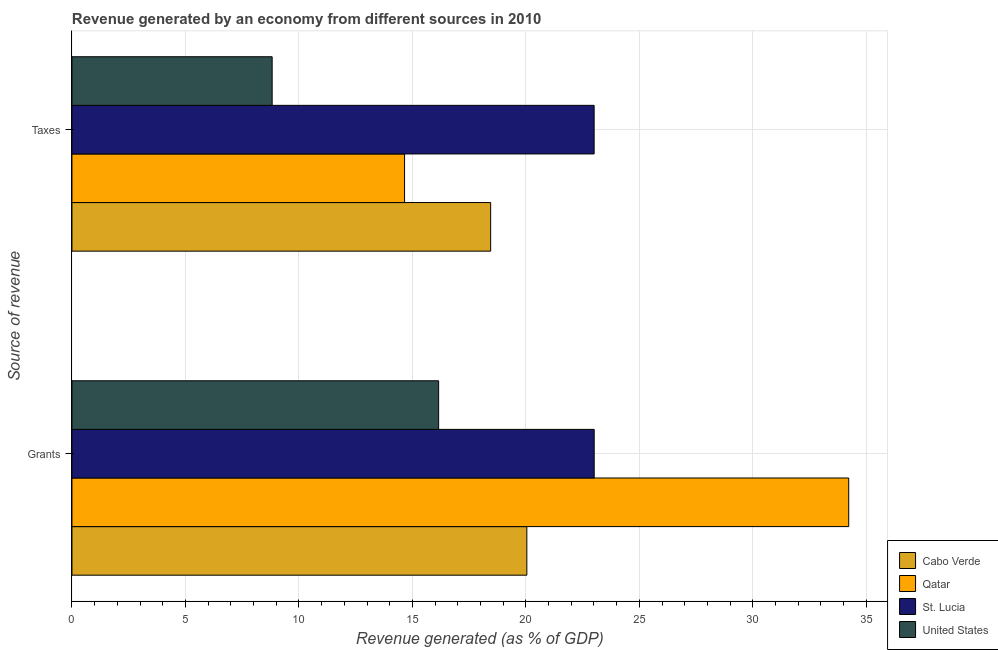How many bars are there on the 2nd tick from the top?
Give a very brief answer. 4. How many bars are there on the 1st tick from the bottom?
Your answer should be compact. 4. What is the label of the 1st group of bars from the top?
Offer a terse response. Taxes. What is the revenue generated by taxes in United States?
Offer a terse response. 8.82. Across all countries, what is the maximum revenue generated by taxes?
Provide a succinct answer. 23.01. Across all countries, what is the minimum revenue generated by taxes?
Offer a very short reply. 8.82. In which country was the revenue generated by taxes maximum?
Keep it short and to the point. St. Lucia. In which country was the revenue generated by taxes minimum?
Your response must be concise. United States. What is the total revenue generated by grants in the graph?
Keep it short and to the point. 93.43. What is the difference between the revenue generated by taxes in St. Lucia and that in Qatar?
Your answer should be compact. 8.35. What is the difference between the revenue generated by taxes in Qatar and the revenue generated by grants in St. Lucia?
Your response must be concise. -8.36. What is the average revenue generated by grants per country?
Your answer should be very brief. 23.36. What is the difference between the revenue generated by taxes and revenue generated by grants in Qatar?
Make the answer very short. -19.57. In how many countries, is the revenue generated by grants greater than 27 %?
Offer a terse response. 1. What is the ratio of the revenue generated by grants in Qatar to that in United States?
Your answer should be very brief. 2.12. Is the revenue generated by taxes in United States less than that in Qatar?
Give a very brief answer. Yes. In how many countries, is the revenue generated by taxes greater than the average revenue generated by taxes taken over all countries?
Offer a terse response. 2. What does the 4th bar from the top in Grants represents?
Give a very brief answer. Cabo Verde. What does the 3rd bar from the bottom in Taxes represents?
Give a very brief answer. St. Lucia. How many countries are there in the graph?
Keep it short and to the point. 4. What is the difference between two consecutive major ticks on the X-axis?
Make the answer very short. 5. Are the values on the major ticks of X-axis written in scientific E-notation?
Offer a very short reply. No. Does the graph contain any zero values?
Your response must be concise. No. Where does the legend appear in the graph?
Provide a short and direct response. Bottom right. How are the legend labels stacked?
Provide a succinct answer. Vertical. What is the title of the graph?
Keep it short and to the point. Revenue generated by an economy from different sources in 2010. What is the label or title of the X-axis?
Provide a short and direct response. Revenue generated (as % of GDP). What is the label or title of the Y-axis?
Offer a terse response. Source of revenue. What is the Revenue generated (as % of GDP) of Cabo Verde in Grants?
Keep it short and to the point. 20.04. What is the Revenue generated (as % of GDP) in Qatar in Grants?
Provide a succinct answer. 34.22. What is the Revenue generated (as % of GDP) of St. Lucia in Grants?
Offer a terse response. 23.01. What is the Revenue generated (as % of GDP) in United States in Grants?
Your answer should be very brief. 16.16. What is the Revenue generated (as % of GDP) of Cabo Verde in Taxes?
Your answer should be very brief. 18.45. What is the Revenue generated (as % of GDP) in Qatar in Taxes?
Your answer should be very brief. 14.65. What is the Revenue generated (as % of GDP) in St. Lucia in Taxes?
Make the answer very short. 23.01. What is the Revenue generated (as % of GDP) in United States in Taxes?
Give a very brief answer. 8.82. Across all Source of revenue, what is the maximum Revenue generated (as % of GDP) in Cabo Verde?
Make the answer very short. 20.04. Across all Source of revenue, what is the maximum Revenue generated (as % of GDP) of Qatar?
Your response must be concise. 34.22. Across all Source of revenue, what is the maximum Revenue generated (as % of GDP) in St. Lucia?
Make the answer very short. 23.01. Across all Source of revenue, what is the maximum Revenue generated (as % of GDP) in United States?
Your answer should be very brief. 16.16. Across all Source of revenue, what is the minimum Revenue generated (as % of GDP) of Cabo Verde?
Keep it short and to the point. 18.45. Across all Source of revenue, what is the minimum Revenue generated (as % of GDP) of Qatar?
Make the answer very short. 14.65. Across all Source of revenue, what is the minimum Revenue generated (as % of GDP) of St. Lucia?
Give a very brief answer. 23.01. Across all Source of revenue, what is the minimum Revenue generated (as % of GDP) in United States?
Offer a very short reply. 8.82. What is the total Revenue generated (as % of GDP) in Cabo Verde in the graph?
Provide a succinct answer. 38.49. What is the total Revenue generated (as % of GDP) in Qatar in the graph?
Provide a short and direct response. 48.88. What is the total Revenue generated (as % of GDP) of St. Lucia in the graph?
Your answer should be very brief. 46.02. What is the total Revenue generated (as % of GDP) of United States in the graph?
Provide a short and direct response. 24.98. What is the difference between the Revenue generated (as % of GDP) of Cabo Verde in Grants and that in Taxes?
Offer a very short reply. 1.59. What is the difference between the Revenue generated (as % of GDP) of Qatar in Grants and that in Taxes?
Your answer should be compact. 19.57. What is the difference between the Revenue generated (as % of GDP) of St. Lucia in Grants and that in Taxes?
Make the answer very short. 0. What is the difference between the Revenue generated (as % of GDP) in United States in Grants and that in Taxes?
Offer a terse response. 7.34. What is the difference between the Revenue generated (as % of GDP) in Cabo Verde in Grants and the Revenue generated (as % of GDP) in Qatar in Taxes?
Make the answer very short. 5.39. What is the difference between the Revenue generated (as % of GDP) of Cabo Verde in Grants and the Revenue generated (as % of GDP) of St. Lucia in Taxes?
Make the answer very short. -2.96. What is the difference between the Revenue generated (as % of GDP) in Cabo Verde in Grants and the Revenue generated (as % of GDP) in United States in Taxes?
Give a very brief answer. 11.22. What is the difference between the Revenue generated (as % of GDP) of Qatar in Grants and the Revenue generated (as % of GDP) of St. Lucia in Taxes?
Ensure brevity in your answer.  11.22. What is the difference between the Revenue generated (as % of GDP) of Qatar in Grants and the Revenue generated (as % of GDP) of United States in Taxes?
Give a very brief answer. 25.4. What is the difference between the Revenue generated (as % of GDP) in St. Lucia in Grants and the Revenue generated (as % of GDP) in United States in Taxes?
Your response must be concise. 14.19. What is the average Revenue generated (as % of GDP) in Cabo Verde per Source of revenue?
Ensure brevity in your answer.  19.25. What is the average Revenue generated (as % of GDP) in Qatar per Source of revenue?
Provide a succinct answer. 24.44. What is the average Revenue generated (as % of GDP) in St. Lucia per Source of revenue?
Ensure brevity in your answer.  23.01. What is the average Revenue generated (as % of GDP) of United States per Source of revenue?
Your response must be concise. 12.49. What is the difference between the Revenue generated (as % of GDP) of Cabo Verde and Revenue generated (as % of GDP) of Qatar in Grants?
Provide a short and direct response. -14.18. What is the difference between the Revenue generated (as % of GDP) of Cabo Verde and Revenue generated (as % of GDP) of St. Lucia in Grants?
Provide a short and direct response. -2.97. What is the difference between the Revenue generated (as % of GDP) of Cabo Verde and Revenue generated (as % of GDP) of United States in Grants?
Keep it short and to the point. 3.89. What is the difference between the Revenue generated (as % of GDP) in Qatar and Revenue generated (as % of GDP) in St. Lucia in Grants?
Provide a succinct answer. 11.21. What is the difference between the Revenue generated (as % of GDP) in Qatar and Revenue generated (as % of GDP) in United States in Grants?
Your answer should be compact. 18.07. What is the difference between the Revenue generated (as % of GDP) of St. Lucia and Revenue generated (as % of GDP) of United States in Grants?
Your response must be concise. 6.85. What is the difference between the Revenue generated (as % of GDP) of Cabo Verde and Revenue generated (as % of GDP) of Qatar in Taxes?
Ensure brevity in your answer.  3.79. What is the difference between the Revenue generated (as % of GDP) in Cabo Verde and Revenue generated (as % of GDP) in St. Lucia in Taxes?
Keep it short and to the point. -4.56. What is the difference between the Revenue generated (as % of GDP) of Cabo Verde and Revenue generated (as % of GDP) of United States in Taxes?
Your answer should be very brief. 9.63. What is the difference between the Revenue generated (as % of GDP) in Qatar and Revenue generated (as % of GDP) in St. Lucia in Taxes?
Offer a terse response. -8.35. What is the difference between the Revenue generated (as % of GDP) of Qatar and Revenue generated (as % of GDP) of United States in Taxes?
Make the answer very short. 5.83. What is the difference between the Revenue generated (as % of GDP) of St. Lucia and Revenue generated (as % of GDP) of United States in Taxes?
Offer a terse response. 14.19. What is the ratio of the Revenue generated (as % of GDP) of Cabo Verde in Grants to that in Taxes?
Your answer should be very brief. 1.09. What is the ratio of the Revenue generated (as % of GDP) of Qatar in Grants to that in Taxes?
Provide a succinct answer. 2.34. What is the ratio of the Revenue generated (as % of GDP) of United States in Grants to that in Taxes?
Your answer should be compact. 1.83. What is the difference between the highest and the second highest Revenue generated (as % of GDP) in Cabo Verde?
Make the answer very short. 1.59. What is the difference between the highest and the second highest Revenue generated (as % of GDP) in Qatar?
Provide a short and direct response. 19.57. What is the difference between the highest and the second highest Revenue generated (as % of GDP) of St. Lucia?
Provide a succinct answer. 0. What is the difference between the highest and the second highest Revenue generated (as % of GDP) of United States?
Your response must be concise. 7.34. What is the difference between the highest and the lowest Revenue generated (as % of GDP) of Cabo Verde?
Offer a very short reply. 1.59. What is the difference between the highest and the lowest Revenue generated (as % of GDP) of Qatar?
Provide a succinct answer. 19.57. What is the difference between the highest and the lowest Revenue generated (as % of GDP) of St. Lucia?
Ensure brevity in your answer.  0. What is the difference between the highest and the lowest Revenue generated (as % of GDP) in United States?
Your answer should be very brief. 7.34. 